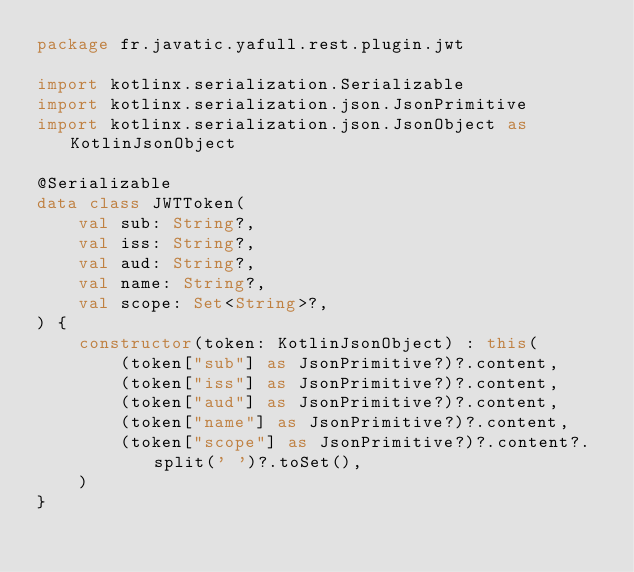<code> <loc_0><loc_0><loc_500><loc_500><_Kotlin_>package fr.javatic.yafull.rest.plugin.jwt

import kotlinx.serialization.Serializable
import kotlinx.serialization.json.JsonPrimitive
import kotlinx.serialization.json.JsonObject as KotlinJsonObject

@Serializable
data class JWTToken(
    val sub: String?,
    val iss: String?,
    val aud: String?,
    val name: String?,
    val scope: Set<String>?,
) {
    constructor(token: KotlinJsonObject) : this(
        (token["sub"] as JsonPrimitive?)?.content,
        (token["iss"] as JsonPrimitive?)?.content,
        (token["aud"] as JsonPrimitive?)?.content,
        (token["name"] as JsonPrimitive?)?.content,
        (token["scope"] as JsonPrimitive?)?.content?.split(' ')?.toSet(),
    )
}
</code> 